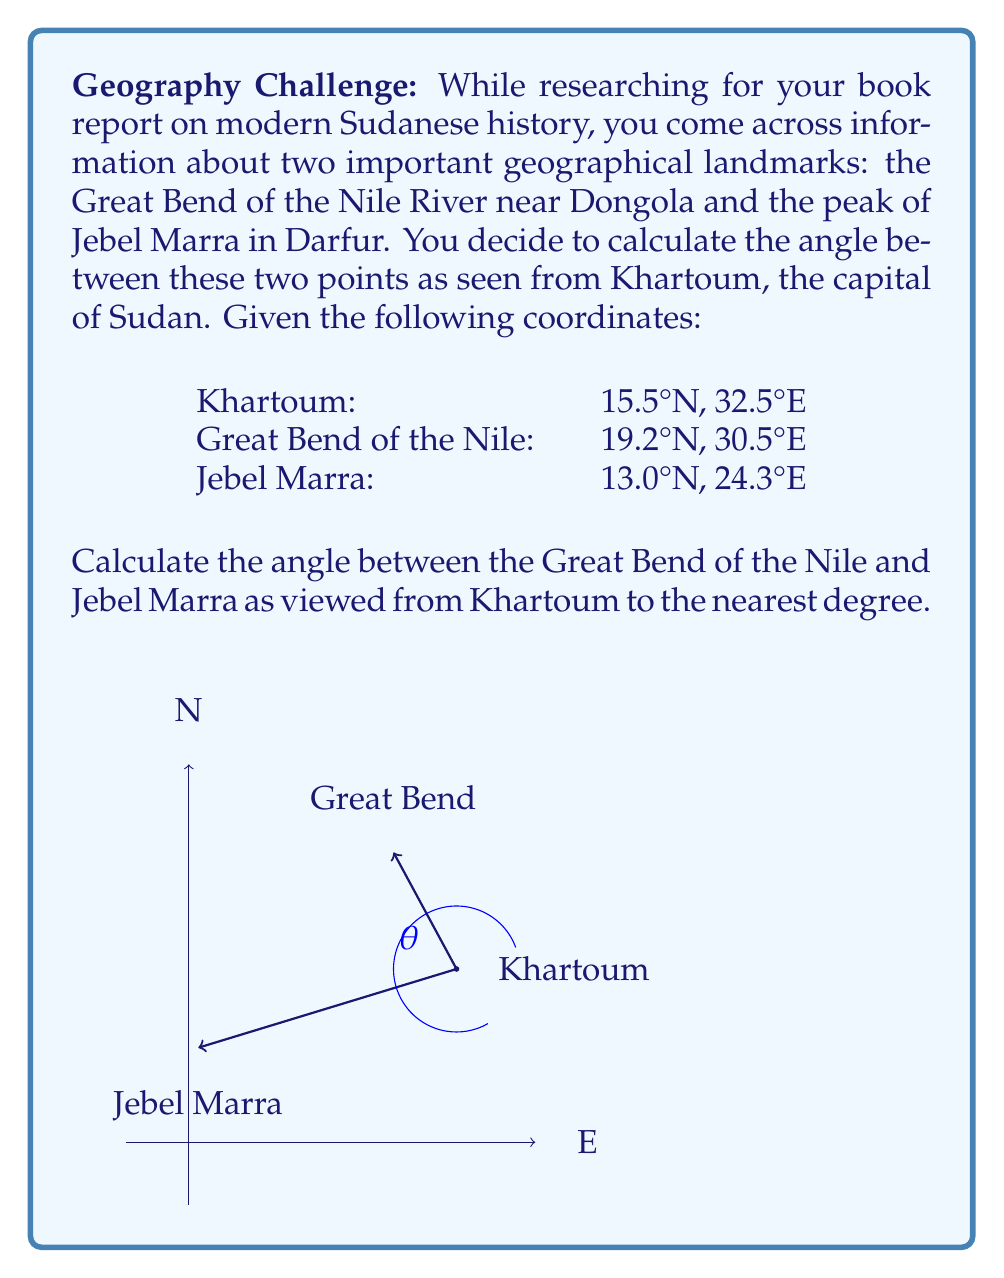Teach me how to tackle this problem. To solve this problem, we'll use the concept of vectors and the dot product. Let's follow these steps:

1) First, we need to convert the geographical coordinates to vectors with Khartoum as the origin:

   Great Bend vector: $\vec{v_1} = (30.5 - 32.5, 19.2 - 15.5) = (-2, 3.7)$
   Jebel Marra vector: $\vec{v_2} = (24.3 - 32.5, 13.0 - 15.5) = (-8.2, -2.5)$

2) Now, we can use the dot product formula to find the angle between these vectors:

   $\cos \theta = \frac{\vec{v_1} \cdot \vec{v_2}}{|\vec{v_1}| |\vec{v_2}|}$

3) Let's calculate each part:
   
   $\vec{v_1} \cdot \vec{v_2} = (-2)(-8.2) + (3.7)(-2.5) = 16.4 - 9.25 = 7.15$
   
   $|\vec{v_1}| = \sqrt{(-2)^2 + (3.7)^2} = \sqrt{4 + 13.69} = \sqrt{17.69} = 4.21$
   
   $|\vec{v_2}| = \sqrt{(-8.2)^2 + (-2.5)^2} = \sqrt{67.24 + 6.25} = \sqrt{73.49} = 8.57$

4) Substituting into the formula:

   $\cos \theta = \frac{7.15}{4.21 \times 8.57} = \frac{7.15}{36.08} = 0.1981$

5) To get the angle, we take the inverse cosine (arccos):

   $\theta = \arccos(0.1981) = 78.57°$

6) Rounding to the nearest degree:

   $\theta \approx 79°$
Answer: 79° 